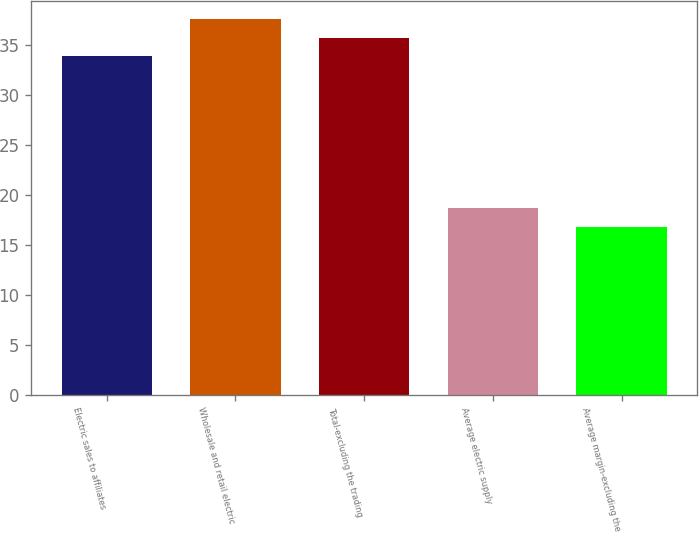<chart> <loc_0><loc_0><loc_500><loc_500><bar_chart><fcel>Electric sales to affiliates<fcel>Wholesale and retail electric<fcel>Total-excluding the trading<fcel>Average electric supply<fcel>Average margin-excluding the<nl><fcel>33.94<fcel>37.58<fcel>35.76<fcel>18.65<fcel>16.83<nl></chart> 